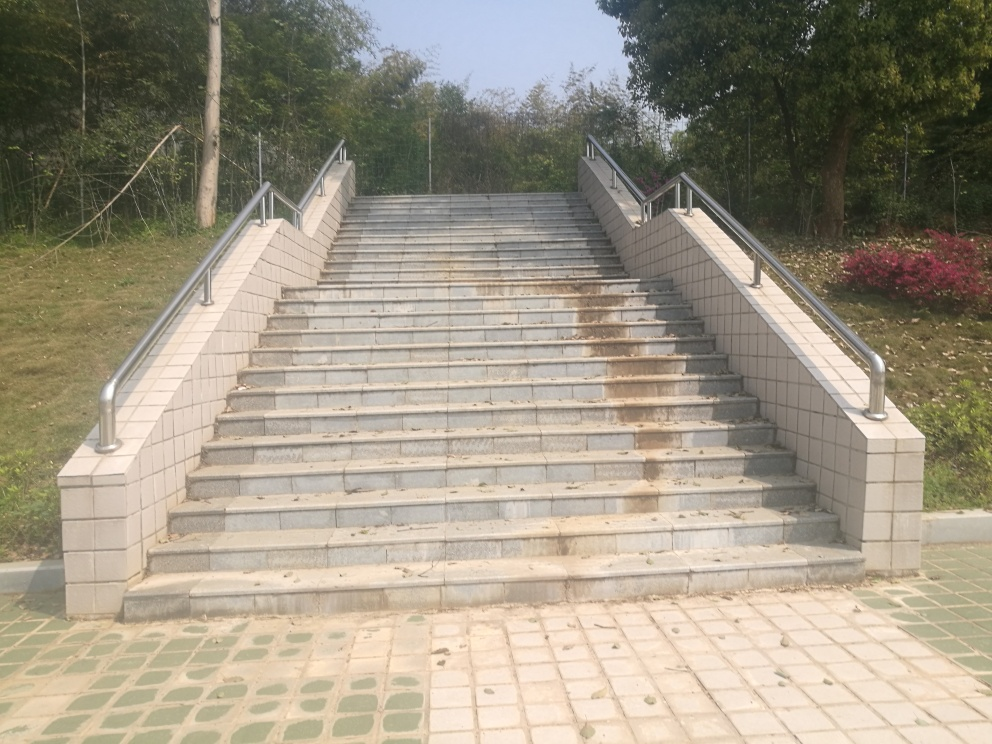How many steps are there in the staircase? It's not possible to provide an exact count from this perspective, but based on the visible sections, one could estimate there are around 20 to 25 steps. 